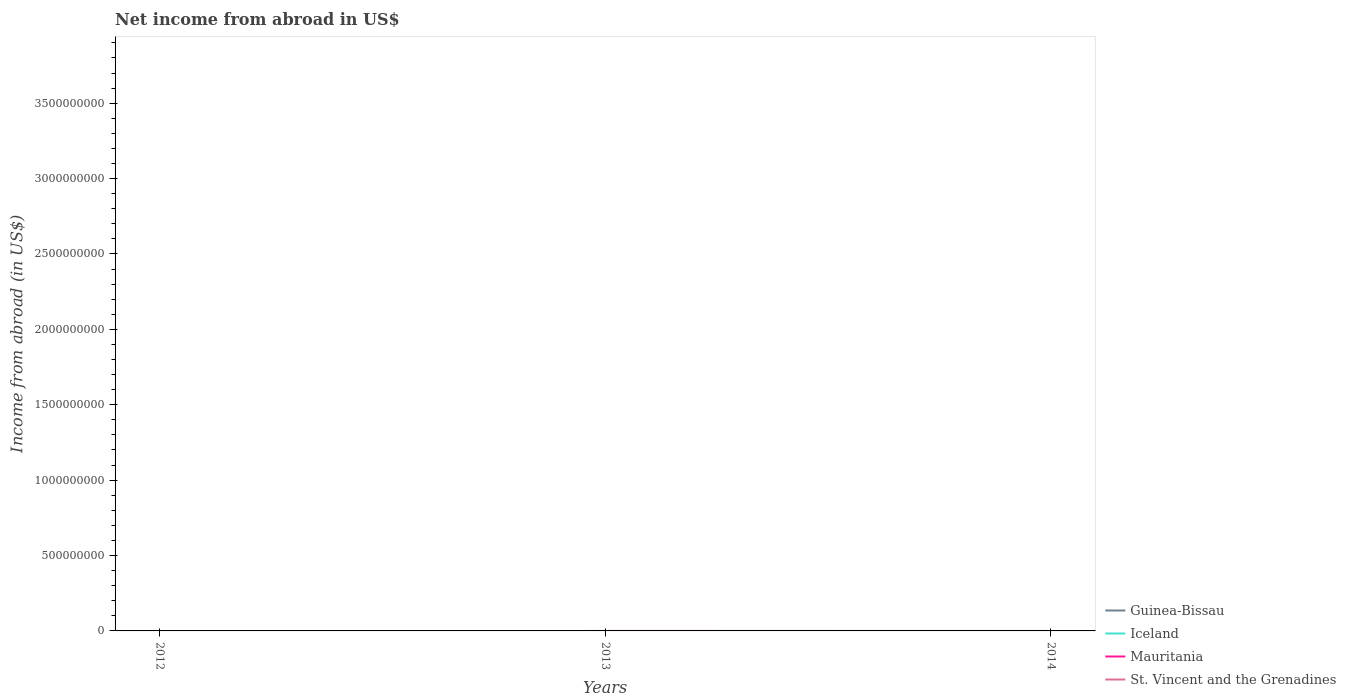Does the line corresponding to St. Vincent and the Grenadines intersect with the line corresponding to Iceland?
Provide a short and direct response. No. Across all years, what is the maximum net income from abroad in Guinea-Bissau?
Make the answer very short. 0. Is the net income from abroad in St. Vincent and the Grenadines strictly greater than the net income from abroad in Guinea-Bissau over the years?
Provide a short and direct response. No. What is the difference between two consecutive major ticks on the Y-axis?
Ensure brevity in your answer.  5.00e+08. Does the graph contain any zero values?
Give a very brief answer. Yes. Does the graph contain grids?
Your answer should be compact. No. Where does the legend appear in the graph?
Give a very brief answer. Bottom right. How many legend labels are there?
Your answer should be very brief. 4. What is the title of the graph?
Ensure brevity in your answer.  Net income from abroad in US$. Does "American Samoa" appear as one of the legend labels in the graph?
Offer a very short reply. No. What is the label or title of the Y-axis?
Provide a short and direct response. Income from abroad (in US$). What is the Income from abroad (in US$) in Iceland in 2012?
Give a very brief answer. 0. What is the Income from abroad (in US$) in Iceland in 2013?
Give a very brief answer. 0. What is the Income from abroad (in US$) of Mauritania in 2013?
Offer a very short reply. 0. What is the Income from abroad (in US$) of St. Vincent and the Grenadines in 2013?
Offer a very short reply. 1.37e+05. What is the Income from abroad (in US$) of Guinea-Bissau in 2014?
Your answer should be very brief. 0. What is the Income from abroad (in US$) of Iceland in 2014?
Your response must be concise. 0. What is the Income from abroad (in US$) in Mauritania in 2014?
Offer a very short reply. 0. Across all years, what is the maximum Income from abroad (in US$) of St. Vincent and the Grenadines?
Your response must be concise. 1.37e+05. Across all years, what is the minimum Income from abroad (in US$) of St. Vincent and the Grenadines?
Ensure brevity in your answer.  0. What is the total Income from abroad (in US$) in Iceland in the graph?
Your response must be concise. 0. What is the total Income from abroad (in US$) in St. Vincent and the Grenadines in the graph?
Your response must be concise. 1.37e+05. What is the average Income from abroad (in US$) of Guinea-Bissau per year?
Offer a very short reply. 0. What is the average Income from abroad (in US$) of Iceland per year?
Ensure brevity in your answer.  0. What is the average Income from abroad (in US$) of Mauritania per year?
Ensure brevity in your answer.  0. What is the average Income from abroad (in US$) of St. Vincent and the Grenadines per year?
Give a very brief answer. 4.58e+04. What is the difference between the highest and the lowest Income from abroad (in US$) in St. Vincent and the Grenadines?
Provide a short and direct response. 1.37e+05. 